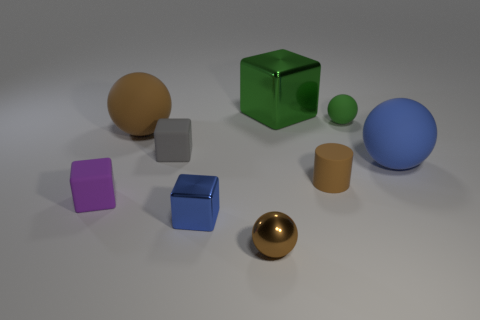What number of rubber things are large blocks or green balls?
Offer a terse response. 1. Are there any cyan shiny balls of the same size as the green metal object?
Ensure brevity in your answer.  No. Is the number of big brown spheres behind the large brown rubber object greater than the number of brown spheres?
Your response must be concise. No. What number of big objects are matte balls or brown things?
Ensure brevity in your answer.  2. What number of large matte things have the same shape as the small purple thing?
Provide a succinct answer. 0. There is a tiny sphere behind the small sphere in front of the gray matte thing; what is its material?
Keep it short and to the point. Rubber. What is the size of the brown object that is in front of the tiny purple matte thing?
Offer a terse response. Small. What number of gray objects are either small cylinders or cubes?
Your answer should be very brief. 1. Is there any other thing that has the same material as the big cube?
Keep it short and to the point. Yes. There is a blue object that is the same shape as the tiny purple matte object; what is its material?
Offer a terse response. Metal. 